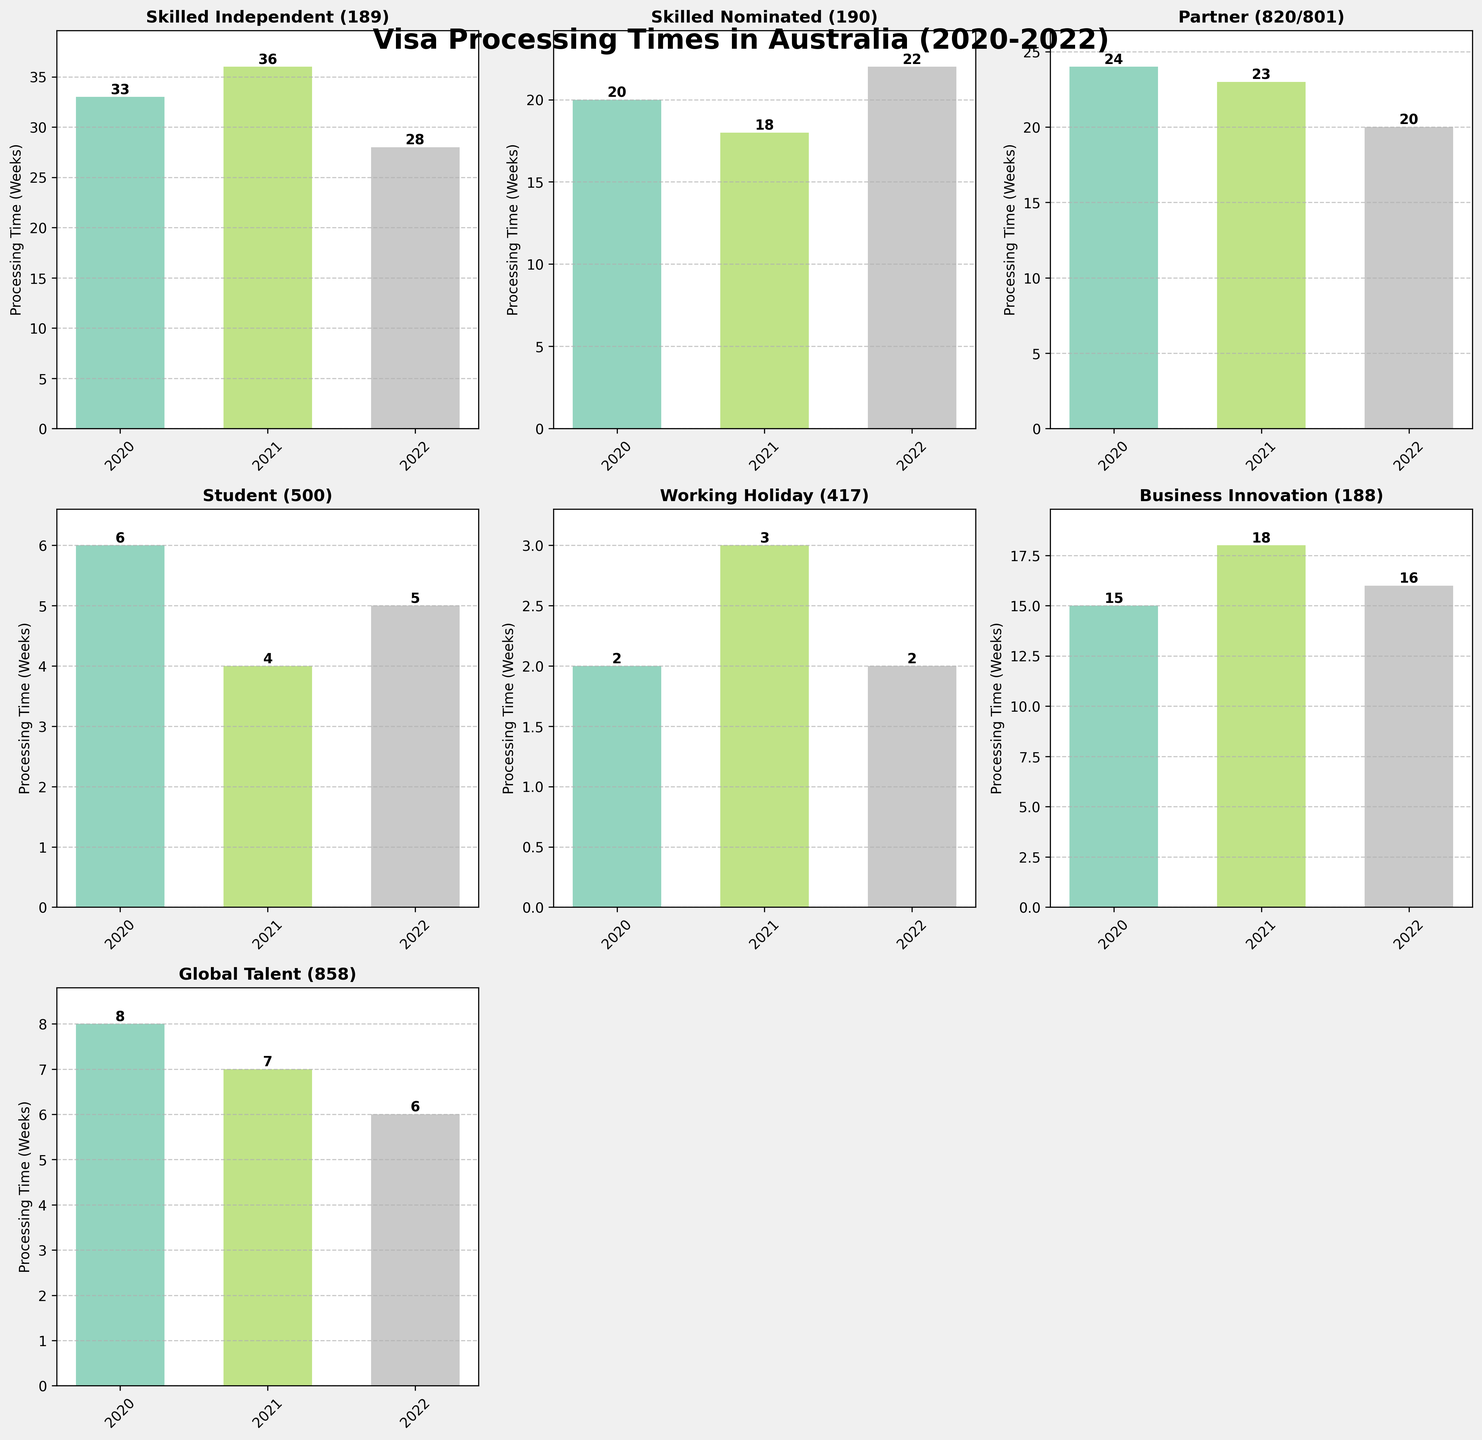What is the title of the figure? The title of the figure is located at the top of the plot and it provides a brief description of the overall content. In this case, the title is "Visa Processing Times in Australia (2020-2022)".
Answer: Visa Processing Times in Australia (2020-2022) What is the processing time for the Skilled Independent (189) visa category in 2022? Find the subplot titled "Skilled Independent (189)". Locate the bar corresponding to the year 2022. The number on top of this bar indicates the processing time. The processing time for 2022 is 28 weeks.
Answer: 28 weeks Which visa category had the shortest processing time in 2021? To determine this, look at all the subplots and focus on the bars representing the year 2021. Identify the shortest bar, which corresponds to the visa category "Student (500)" with a processing time of 4 weeks.
Answer: Student (500) Did the processing time for the Partner (820/801) visa category increase or decrease from 2021 to 2022? Locate the subplot titled "Partner (820/801)". Compare the heights of the bars for the years 2021 and 2022. The height of the bar for 2022 is lower than that for 2021, indicating a decrease in processing time.
Answer: Decrease What is the average processing time for the Business Innovation (188) visa category over the years 2020-2022? Calculate the average by summing the processing times for the years 2020, 2021, and 2022, then divide by the number of years. Processing times are 15 (2020), 18 (2021), and 16 (2022). The average is (15 + 18 + 16) / 3 = 49 / 3 = 16.33 weeks.
Answer: 16.33 weeks Which visa category shows the most consistent processing time over the period 2020-2022? Consistency can be gauged by the amount of variation in processing times over the years. Identify the visa category with bars of nearly equal height across the years. "Working Holiday (417)" and "Global Talent (858)" are candidates, both show very little variation.
Answer: Working Holiday (417) or Global Talent (858) Has the processing time for Skilled Nominated (190) visa been generally increasing, decreasing, or fluctuating from 2020 to 2022? Locate the subplot titled "Skilled Nominated (190)" and observe the trends in bar heights. The processing time decreased from 2020 to 2021 and then increased in 2022. Therefore, it has been fluctuating.
Answer: Fluctuating What is the difference in processing time between Student (500) and Business Innovation (188) visa categories in 2021? Find the bar heights for "Student (500)" and "Business Innovation (188)" in the year 2021. Processing times are 4 weeks for Student (500) and 18 weeks for Business Innovation (188). Difference = 18 - 4 = 14 weeks.
Answer: 14 weeks Which visa category had a processing time of more than 30 weeks in any year? Look across all subplots for any bars extending above the 30-week mark. The "Skilled Independent (189)" category in 2020 (33 weeks) and 2021 (36 weeks) fit this criterion.
Answer: Skilled Independent (189) How did the processing times for Global Talent (858) change from 2020 to 2022? Locate the "Global Talent (858)" subplot and observe the bars for the years 2020, 2021, and 2022. The heights show a steady decrease in processing times: 8 weeks (2020), 7 weeks (2021), and 6 weeks (2022).
Answer: Decreased 